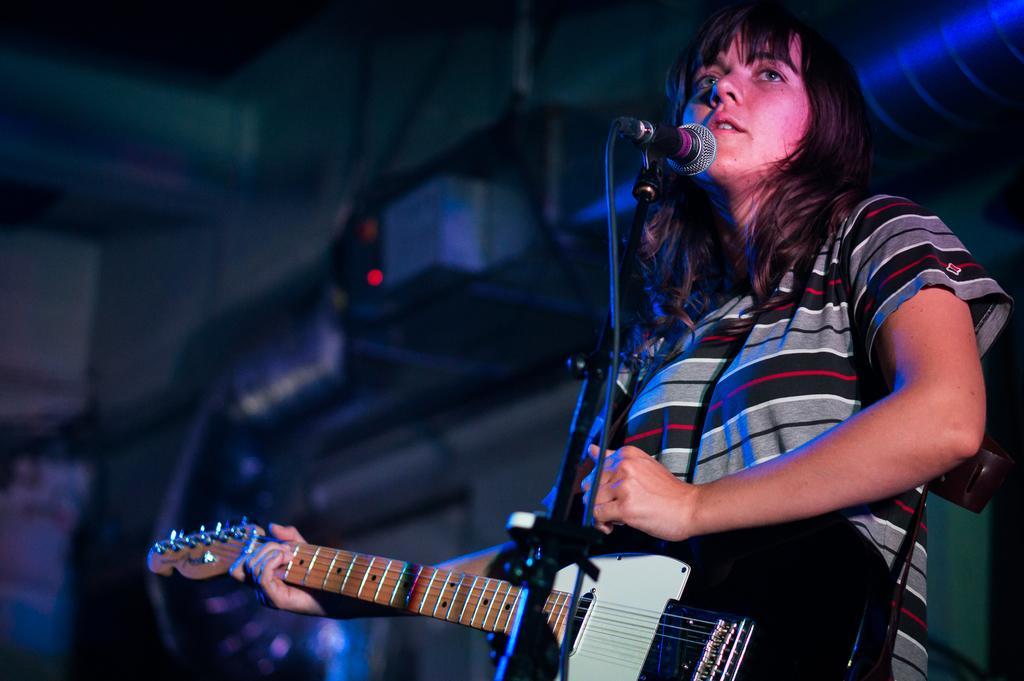Can you describe this image briefly? The women is holding a black guitar in her hand and singing in front of a mike. 